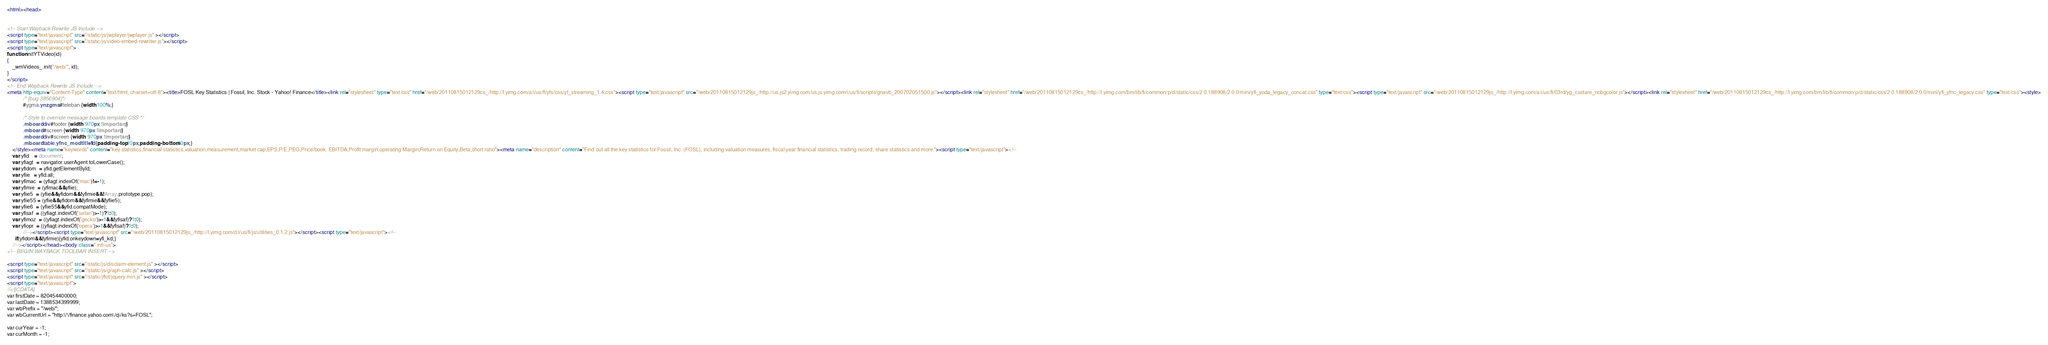Convert code to text. <code><loc_0><loc_0><loc_500><loc_500><_HTML_><html><head>


<!-- Start Wayback Rewrite JS Include -->
<script type="text/javascript" src="/static/js/jwplayer/jwplayer.js" ></script>
<script type="text/javascript" src="/static/js/video-embed-rewriter.js"></script>
<script type="text/javascript">
function initYTVideo(id)
{
	_wmVideos_.init("/web/", id);
}
</script>
<!-- End Wayback Rewrite JS Include -->
<meta http-equiv="Content-Type" content="text/html; charset=utf-8"><title>FOSL Key Statistics | Fossil, Inc. Stock - Yahoo! Finance</title><link rel="stylesheet" type="text/css" href="/web/20110815012129cs_/http://l.yimg.com/a/i/us/fi/yfs/css/yf_streaming_1.4.css"><script type="text/javascript" src="/web/20110815012129js_/http://us.js2.yimg.com/us.js.yimg.com/i/us/fi/scripts/gnavb_200702051500.js"></script><link rel="stylesheet" href="/web/20110815012129cs_/http://l.yimg.com/bm/lib/fi/common/p/d/static/css/2.0.188908/2.0.0/mini/yfi_yoda_legacy_concat.css" type="text/css"><script type="text/javascript" src="/web/20110815012129js_/http://l.yimg.com/a/i/us/fi/03rd/yg_csstare_nobgcolor.js"></script><link rel="stylesheet" href="/web/20110815012129cs_/http://l.yimg.com/bm/lib/fi/common/p/d/static/css/2.0.188908/2.0.0/mini/yfi_yfnc_legacy.css" type="text/css"><style>
       	    /* [bug 3856904]*/
            #ygma.ynzgma #teleban {width:100%;}
            
            /* Style to override message boards template CSS */
            .mboard div#footer {width: 970px !important;}
            .mboard #screen {width: 970px !important;}
            .mboard div#screen {width: 970px !important;}
            .mboard table.yfnc_modtitle1 td{padding-top:10px;padding-bottom:10px;} 
	</style><meta name="keywords" content="key statistics,financial statistics,valuation,measurement,market cap,EPS,P/E,PEG,Price/book. EBITDA,Profit margin,operating Margin,Return on Equity,Beta,short ratio"><meta name="description" content="Find out all the key statistics for Fossil, Inc. (FOSL), including valuation measures, fiscal year financial statistics, trading record, share statistics and more."><script type="text/javascript"><!--
    var yfid    = document;
    var yfiagt  = navigator.userAgent.toLowerCase();
    var yfidom  = yfid.getElementById;
    var yfiie   = yfid.all;
    var yfimac  = (yfiagt.indexOf('mac')!=-1);
    var yfimie  = (yfimac&&yfiie);
    var yfiie5  = (yfiie&&yfidom&&!yfimie&&!Array.prototype.pop);
    var yfiie55 = (yfiie&&yfidom&&!yfimie&&!yfiie5);
    var yfiie6  = (yfiie55&&yfid.compatMode);
    var yfisaf  = ((yfiagt.indexOf('safari')>-1)?1:0);
    var yfimoz  = ((yfiagt.indexOf('gecko')>-1&&!yfisaf)?1:0);
    var yfiopr  = ((yfiagt.indexOf('opera')>-1&&!yfisaf)?1:0);
            //--></script><script type="text/javascript" src="/web/20110815012129js_/http://l.yimg.com/d/i/us/fi/js/utilities_0.1.2.js"></script><script type="text/javascript"><!--
      if(yfidom&&!yfimie){yfid.onkeydown=yfi_kd;}
    //--></script></head><body class=" intl-us">
<!-- BEGIN WAYBACK TOOLBAR INSERT -->

<script type="text/javascript" src="/static/js/disclaim-element.js" ></script>
<script type="text/javascript" src="/static/js/graph-calc.js" ></script>
<script type="text/javascript" src="/static/jflot/jquery.min.js" ></script>
<script type="text/javascript">
//<![CDATA[
var firstDate = 820454400000;
var lastDate = 1388534399999;
var wbPrefix = "/web/";
var wbCurrentUrl = "http:\/\/finance.yahoo.com\/q\/ks?s=FOSL";

var curYear = -1;
var curMonth = -1;</code> 